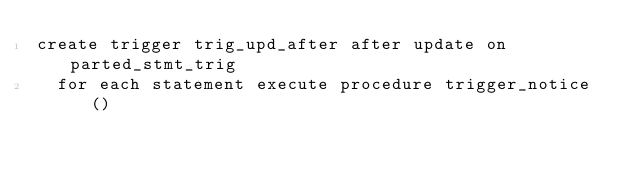<code> <loc_0><loc_0><loc_500><loc_500><_SQL_>create trigger trig_upd_after after update on parted_stmt_trig
  for each statement execute procedure trigger_notice()
</code> 